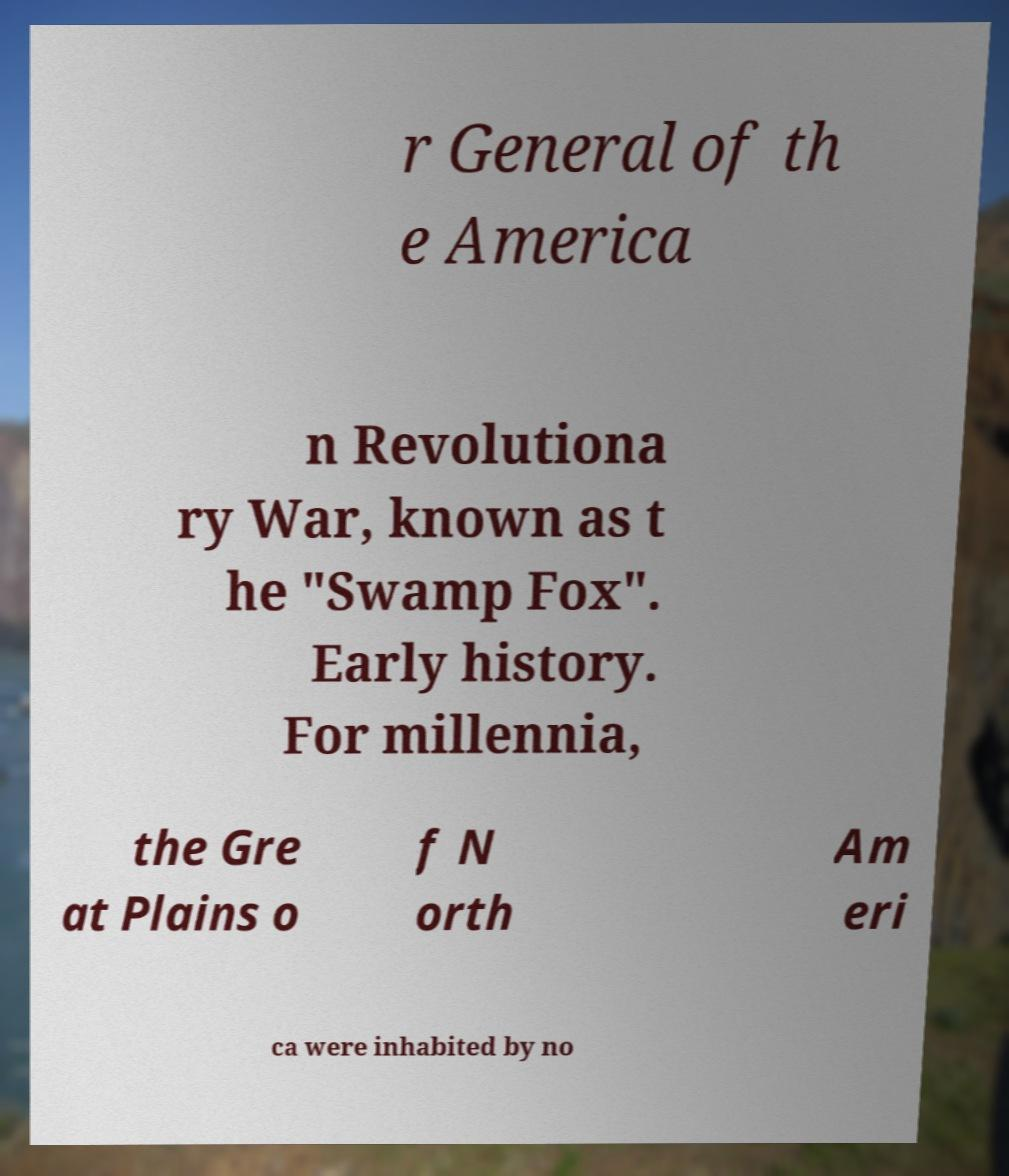For documentation purposes, I need the text within this image transcribed. Could you provide that? r General of th e America n Revolutiona ry War, known as t he "Swamp Fox". Early history. For millennia, the Gre at Plains o f N orth Am eri ca were inhabited by no 